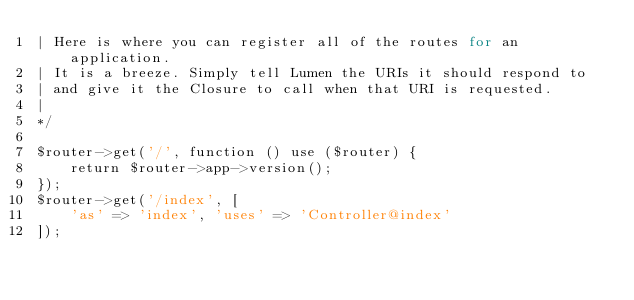<code> <loc_0><loc_0><loc_500><loc_500><_PHP_>| Here is where you can register all of the routes for an application.
| It is a breeze. Simply tell Lumen the URIs it should respond to
| and give it the Closure to call when that URI is requested.
|
*/

$router->get('/', function () use ($router) {
    return $router->app->version();
});
$router->get('/index', [
    'as' => 'index', 'uses' => 'Controller@index'
]);
</code> 